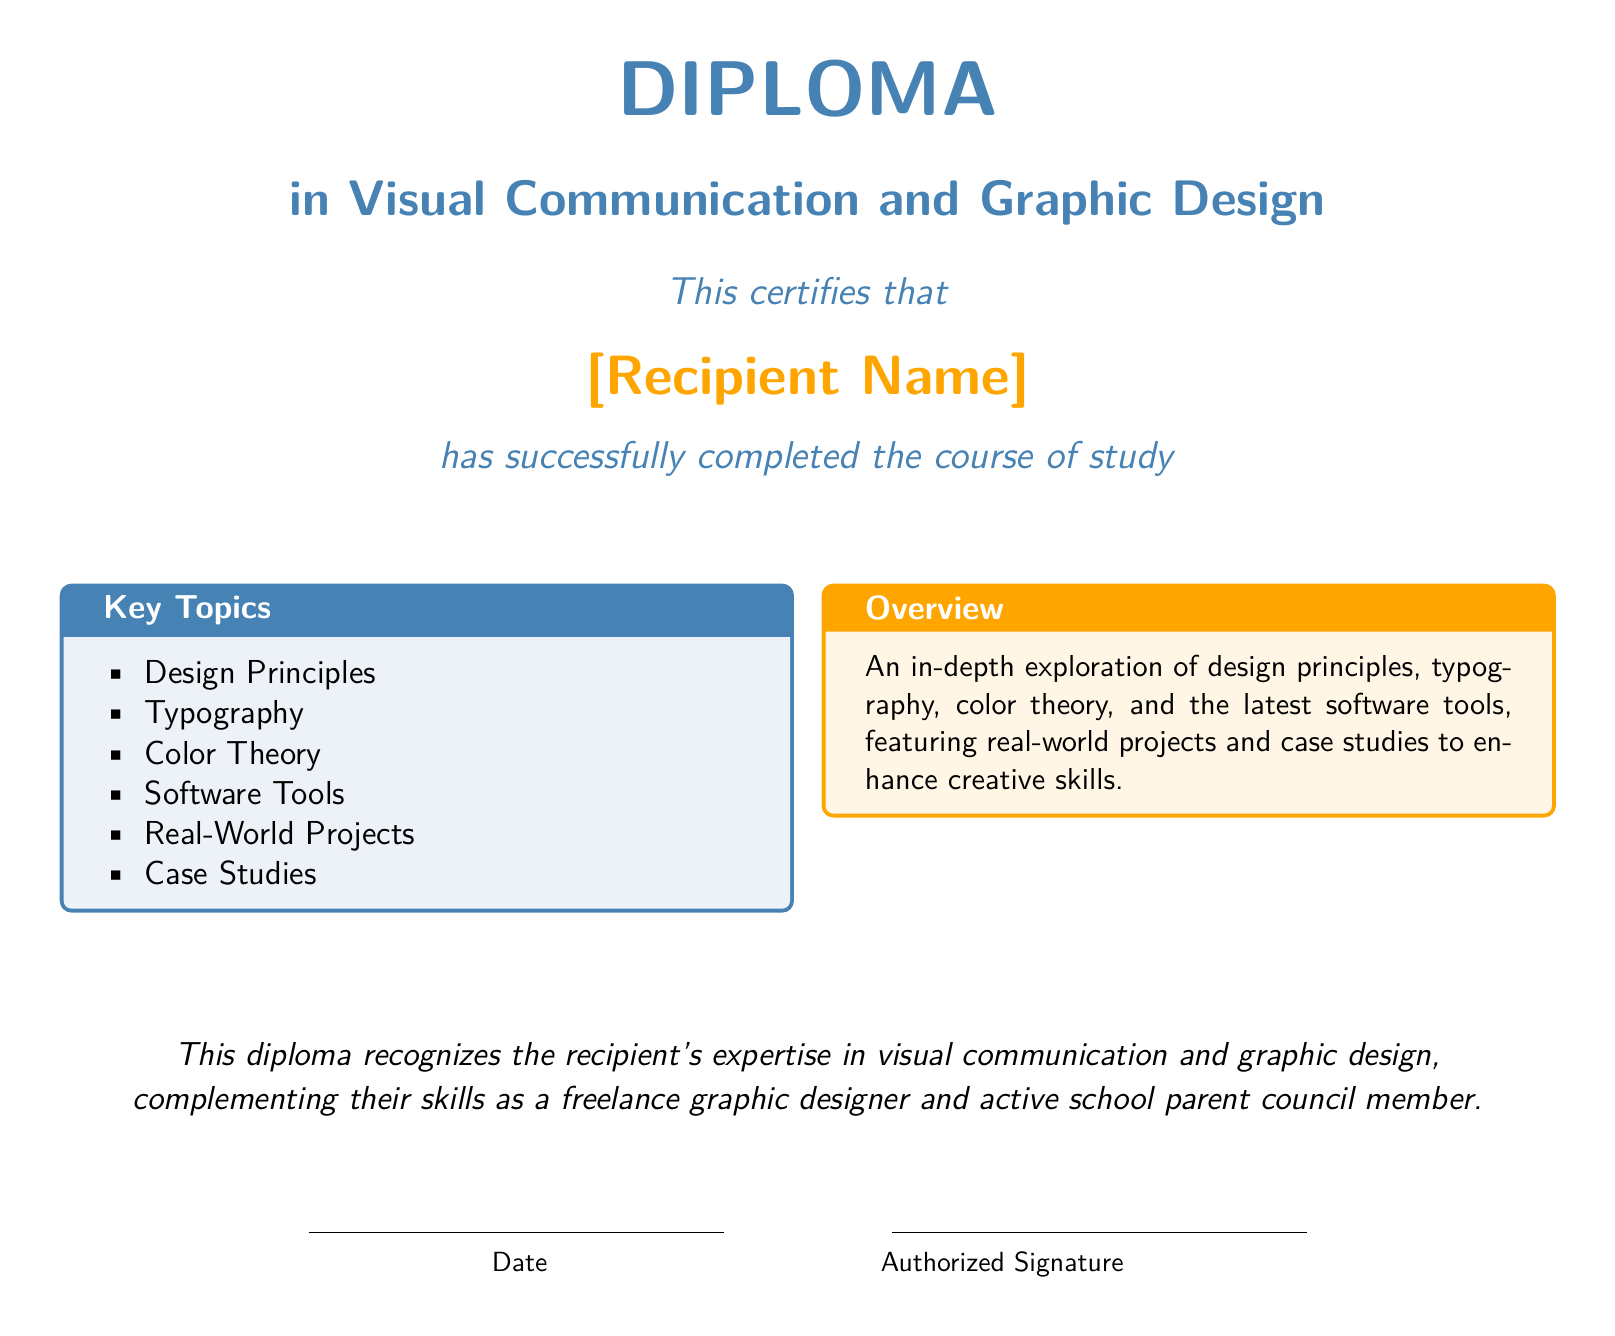What is the title of the diploma? The title of the diploma is explicitly mentioned at the top of the document, highlighting the focus of the course.
Answer: Diploma in Visual Communication and Graphic Design Who is the recipient of the diploma? The document includes a placeholder for the recipient's name, indicating the individual who has received the diploma.
Answer: [Recipient Name] What color is used as the primary color in the document? The primary color is a specific shade defined in the document for emphasis and aesthetic appeal.
Answer: RGB(70,130,180) What key topic is related to typography? The document lists key topics that comprise the curriculum, including one focused specifically on typography.
Answer: Typography What is one of the techniques covered in the Diploma in Flexible Work Management? The document states that the diploma includes techniques for managing various aspects relevant to freelancers, covering a wide range of related skills.
Answer: Scheduling Which skill is recognized by the diploma? The document specifies the expertise acknowledged by the diploma, providing a clear connection to the recipient's professional and community roles.
Answer: Expertise in visual communication and graphic design What is the purpose of the diploma mentioned in the overview section? The overview describes the goal of the diploma program, summarizing its intent and focus areas in a concise manner.
Answer: Enhance creative skills What is the date-line section for? The document includes a designated area for a date, typically indicating when the diploma was awarded.
Answer: Date What does the authorized signature section signify? This section indicates the need for validation of the document by an official, which is a common feature in formal certificates.
Answer: Authorized Signature 